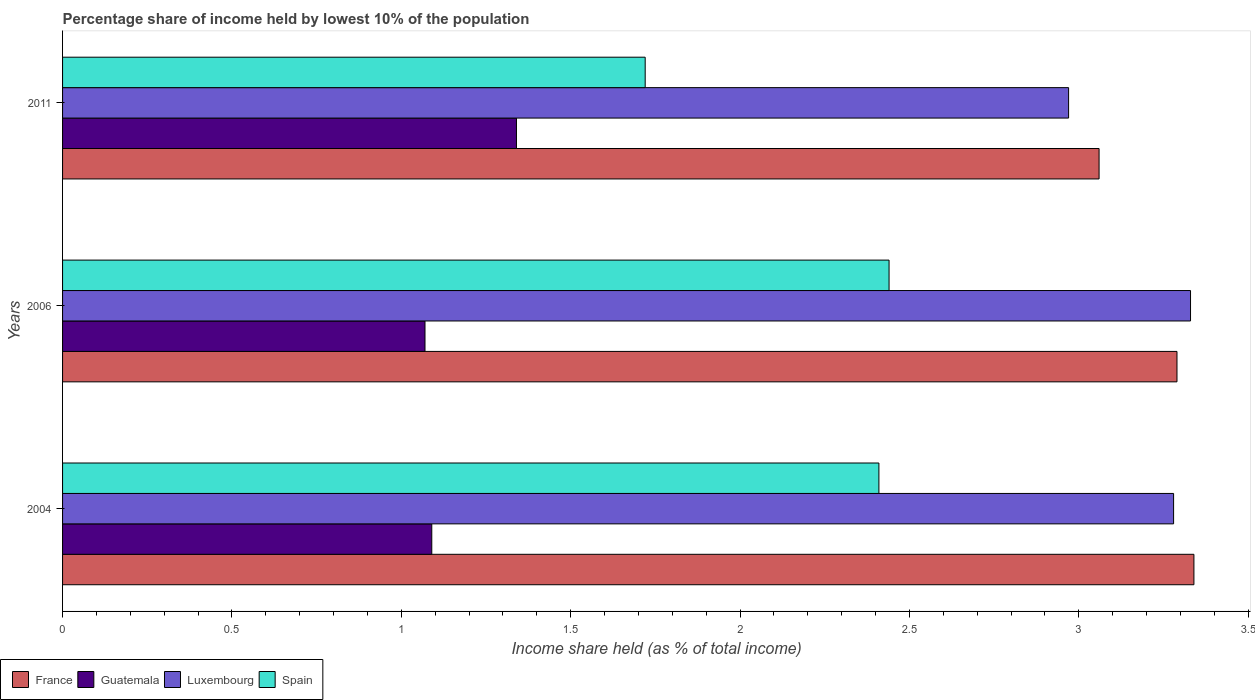How many different coloured bars are there?
Provide a short and direct response. 4. How many groups of bars are there?
Offer a terse response. 3. Are the number of bars per tick equal to the number of legend labels?
Offer a terse response. Yes. How many bars are there on the 1st tick from the top?
Ensure brevity in your answer.  4. What is the label of the 3rd group of bars from the top?
Offer a very short reply. 2004. What is the percentage share of income held by lowest 10% of the population in France in 2006?
Offer a terse response. 3.29. Across all years, what is the maximum percentage share of income held by lowest 10% of the population in France?
Your answer should be compact. 3.34. Across all years, what is the minimum percentage share of income held by lowest 10% of the population in Spain?
Offer a terse response. 1.72. What is the total percentage share of income held by lowest 10% of the population in Luxembourg in the graph?
Ensure brevity in your answer.  9.58. What is the difference between the percentage share of income held by lowest 10% of the population in Guatemala in 2006 and that in 2011?
Keep it short and to the point. -0.27. What is the difference between the percentage share of income held by lowest 10% of the population in France in 2004 and the percentage share of income held by lowest 10% of the population in Luxembourg in 2006?
Provide a short and direct response. 0.01. What is the average percentage share of income held by lowest 10% of the population in Spain per year?
Provide a short and direct response. 2.19. In the year 2011, what is the difference between the percentage share of income held by lowest 10% of the population in Guatemala and percentage share of income held by lowest 10% of the population in Luxembourg?
Your response must be concise. -1.63. What is the ratio of the percentage share of income held by lowest 10% of the population in Luxembourg in 2006 to that in 2011?
Ensure brevity in your answer.  1.12. Is the percentage share of income held by lowest 10% of the population in Luxembourg in 2004 less than that in 2011?
Offer a terse response. No. What is the difference between the highest and the lowest percentage share of income held by lowest 10% of the population in Luxembourg?
Provide a short and direct response. 0.36. In how many years, is the percentage share of income held by lowest 10% of the population in Luxembourg greater than the average percentage share of income held by lowest 10% of the population in Luxembourg taken over all years?
Your response must be concise. 2. What does the 2nd bar from the top in 2011 represents?
Offer a very short reply. Luxembourg. What does the 1st bar from the bottom in 2006 represents?
Provide a short and direct response. France. How many bars are there?
Provide a succinct answer. 12. Are all the bars in the graph horizontal?
Your response must be concise. Yes. How many years are there in the graph?
Keep it short and to the point. 3. What is the difference between two consecutive major ticks on the X-axis?
Ensure brevity in your answer.  0.5. Are the values on the major ticks of X-axis written in scientific E-notation?
Keep it short and to the point. No. Does the graph contain any zero values?
Provide a short and direct response. No. How many legend labels are there?
Your response must be concise. 4. What is the title of the graph?
Keep it short and to the point. Percentage share of income held by lowest 10% of the population. What is the label or title of the X-axis?
Provide a short and direct response. Income share held (as % of total income). What is the Income share held (as % of total income) of France in 2004?
Offer a very short reply. 3.34. What is the Income share held (as % of total income) in Guatemala in 2004?
Ensure brevity in your answer.  1.09. What is the Income share held (as % of total income) in Luxembourg in 2004?
Ensure brevity in your answer.  3.28. What is the Income share held (as % of total income) of Spain in 2004?
Make the answer very short. 2.41. What is the Income share held (as % of total income) in France in 2006?
Provide a succinct answer. 3.29. What is the Income share held (as % of total income) in Guatemala in 2006?
Give a very brief answer. 1.07. What is the Income share held (as % of total income) in Luxembourg in 2006?
Your answer should be very brief. 3.33. What is the Income share held (as % of total income) of Spain in 2006?
Your answer should be very brief. 2.44. What is the Income share held (as % of total income) in France in 2011?
Your answer should be very brief. 3.06. What is the Income share held (as % of total income) of Guatemala in 2011?
Your response must be concise. 1.34. What is the Income share held (as % of total income) in Luxembourg in 2011?
Your answer should be very brief. 2.97. What is the Income share held (as % of total income) in Spain in 2011?
Your answer should be compact. 1.72. Across all years, what is the maximum Income share held (as % of total income) of France?
Ensure brevity in your answer.  3.34. Across all years, what is the maximum Income share held (as % of total income) in Guatemala?
Offer a terse response. 1.34. Across all years, what is the maximum Income share held (as % of total income) of Luxembourg?
Your answer should be very brief. 3.33. Across all years, what is the maximum Income share held (as % of total income) in Spain?
Provide a short and direct response. 2.44. Across all years, what is the minimum Income share held (as % of total income) in France?
Provide a short and direct response. 3.06. Across all years, what is the minimum Income share held (as % of total income) of Guatemala?
Keep it short and to the point. 1.07. Across all years, what is the minimum Income share held (as % of total income) in Luxembourg?
Ensure brevity in your answer.  2.97. Across all years, what is the minimum Income share held (as % of total income) in Spain?
Ensure brevity in your answer.  1.72. What is the total Income share held (as % of total income) in France in the graph?
Make the answer very short. 9.69. What is the total Income share held (as % of total income) of Guatemala in the graph?
Your response must be concise. 3.5. What is the total Income share held (as % of total income) of Luxembourg in the graph?
Your answer should be very brief. 9.58. What is the total Income share held (as % of total income) in Spain in the graph?
Provide a succinct answer. 6.57. What is the difference between the Income share held (as % of total income) of Luxembourg in 2004 and that in 2006?
Your answer should be compact. -0.05. What is the difference between the Income share held (as % of total income) in Spain in 2004 and that in 2006?
Your answer should be compact. -0.03. What is the difference between the Income share held (as % of total income) of France in 2004 and that in 2011?
Give a very brief answer. 0.28. What is the difference between the Income share held (as % of total income) of Luxembourg in 2004 and that in 2011?
Offer a very short reply. 0.31. What is the difference between the Income share held (as % of total income) in Spain in 2004 and that in 2011?
Your answer should be compact. 0.69. What is the difference between the Income share held (as % of total income) of France in 2006 and that in 2011?
Give a very brief answer. 0.23. What is the difference between the Income share held (as % of total income) of Guatemala in 2006 and that in 2011?
Make the answer very short. -0.27. What is the difference between the Income share held (as % of total income) of Luxembourg in 2006 and that in 2011?
Keep it short and to the point. 0.36. What is the difference between the Income share held (as % of total income) in Spain in 2006 and that in 2011?
Make the answer very short. 0.72. What is the difference between the Income share held (as % of total income) in France in 2004 and the Income share held (as % of total income) in Guatemala in 2006?
Make the answer very short. 2.27. What is the difference between the Income share held (as % of total income) of France in 2004 and the Income share held (as % of total income) of Luxembourg in 2006?
Your answer should be compact. 0.01. What is the difference between the Income share held (as % of total income) in Guatemala in 2004 and the Income share held (as % of total income) in Luxembourg in 2006?
Make the answer very short. -2.24. What is the difference between the Income share held (as % of total income) of Guatemala in 2004 and the Income share held (as % of total income) of Spain in 2006?
Keep it short and to the point. -1.35. What is the difference between the Income share held (as % of total income) in Luxembourg in 2004 and the Income share held (as % of total income) in Spain in 2006?
Make the answer very short. 0.84. What is the difference between the Income share held (as % of total income) in France in 2004 and the Income share held (as % of total income) in Guatemala in 2011?
Provide a succinct answer. 2. What is the difference between the Income share held (as % of total income) in France in 2004 and the Income share held (as % of total income) in Luxembourg in 2011?
Provide a succinct answer. 0.37. What is the difference between the Income share held (as % of total income) in France in 2004 and the Income share held (as % of total income) in Spain in 2011?
Keep it short and to the point. 1.62. What is the difference between the Income share held (as % of total income) in Guatemala in 2004 and the Income share held (as % of total income) in Luxembourg in 2011?
Your answer should be compact. -1.88. What is the difference between the Income share held (as % of total income) in Guatemala in 2004 and the Income share held (as % of total income) in Spain in 2011?
Offer a terse response. -0.63. What is the difference between the Income share held (as % of total income) of Luxembourg in 2004 and the Income share held (as % of total income) of Spain in 2011?
Make the answer very short. 1.56. What is the difference between the Income share held (as % of total income) in France in 2006 and the Income share held (as % of total income) in Guatemala in 2011?
Provide a succinct answer. 1.95. What is the difference between the Income share held (as % of total income) of France in 2006 and the Income share held (as % of total income) of Luxembourg in 2011?
Your answer should be very brief. 0.32. What is the difference between the Income share held (as % of total income) of France in 2006 and the Income share held (as % of total income) of Spain in 2011?
Your answer should be compact. 1.57. What is the difference between the Income share held (as % of total income) in Guatemala in 2006 and the Income share held (as % of total income) in Spain in 2011?
Offer a very short reply. -0.65. What is the difference between the Income share held (as % of total income) in Luxembourg in 2006 and the Income share held (as % of total income) in Spain in 2011?
Your answer should be compact. 1.61. What is the average Income share held (as % of total income) in France per year?
Ensure brevity in your answer.  3.23. What is the average Income share held (as % of total income) of Luxembourg per year?
Provide a short and direct response. 3.19. What is the average Income share held (as % of total income) of Spain per year?
Give a very brief answer. 2.19. In the year 2004, what is the difference between the Income share held (as % of total income) of France and Income share held (as % of total income) of Guatemala?
Ensure brevity in your answer.  2.25. In the year 2004, what is the difference between the Income share held (as % of total income) of France and Income share held (as % of total income) of Luxembourg?
Ensure brevity in your answer.  0.06. In the year 2004, what is the difference between the Income share held (as % of total income) in Guatemala and Income share held (as % of total income) in Luxembourg?
Your answer should be compact. -2.19. In the year 2004, what is the difference between the Income share held (as % of total income) of Guatemala and Income share held (as % of total income) of Spain?
Provide a succinct answer. -1.32. In the year 2004, what is the difference between the Income share held (as % of total income) in Luxembourg and Income share held (as % of total income) in Spain?
Provide a short and direct response. 0.87. In the year 2006, what is the difference between the Income share held (as % of total income) in France and Income share held (as % of total income) in Guatemala?
Offer a terse response. 2.22. In the year 2006, what is the difference between the Income share held (as % of total income) in France and Income share held (as % of total income) in Luxembourg?
Your answer should be compact. -0.04. In the year 2006, what is the difference between the Income share held (as % of total income) in France and Income share held (as % of total income) in Spain?
Ensure brevity in your answer.  0.85. In the year 2006, what is the difference between the Income share held (as % of total income) in Guatemala and Income share held (as % of total income) in Luxembourg?
Keep it short and to the point. -2.26. In the year 2006, what is the difference between the Income share held (as % of total income) of Guatemala and Income share held (as % of total income) of Spain?
Provide a short and direct response. -1.37. In the year 2006, what is the difference between the Income share held (as % of total income) in Luxembourg and Income share held (as % of total income) in Spain?
Provide a succinct answer. 0.89. In the year 2011, what is the difference between the Income share held (as % of total income) of France and Income share held (as % of total income) of Guatemala?
Provide a succinct answer. 1.72. In the year 2011, what is the difference between the Income share held (as % of total income) in France and Income share held (as % of total income) in Luxembourg?
Offer a terse response. 0.09. In the year 2011, what is the difference between the Income share held (as % of total income) of France and Income share held (as % of total income) of Spain?
Your answer should be compact. 1.34. In the year 2011, what is the difference between the Income share held (as % of total income) in Guatemala and Income share held (as % of total income) in Luxembourg?
Your response must be concise. -1.63. In the year 2011, what is the difference between the Income share held (as % of total income) in Guatemala and Income share held (as % of total income) in Spain?
Your response must be concise. -0.38. What is the ratio of the Income share held (as % of total income) of France in 2004 to that in 2006?
Make the answer very short. 1.02. What is the ratio of the Income share held (as % of total income) in Guatemala in 2004 to that in 2006?
Your answer should be compact. 1.02. What is the ratio of the Income share held (as % of total income) of Spain in 2004 to that in 2006?
Make the answer very short. 0.99. What is the ratio of the Income share held (as % of total income) in France in 2004 to that in 2011?
Your response must be concise. 1.09. What is the ratio of the Income share held (as % of total income) of Guatemala in 2004 to that in 2011?
Provide a short and direct response. 0.81. What is the ratio of the Income share held (as % of total income) in Luxembourg in 2004 to that in 2011?
Provide a succinct answer. 1.1. What is the ratio of the Income share held (as % of total income) in Spain in 2004 to that in 2011?
Ensure brevity in your answer.  1.4. What is the ratio of the Income share held (as % of total income) of France in 2006 to that in 2011?
Your answer should be very brief. 1.08. What is the ratio of the Income share held (as % of total income) of Guatemala in 2006 to that in 2011?
Provide a succinct answer. 0.8. What is the ratio of the Income share held (as % of total income) in Luxembourg in 2006 to that in 2011?
Ensure brevity in your answer.  1.12. What is the ratio of the Income share held (as % of total income) of Spain in 2006 to that in 2011?
Make the answer very short. 1.42. What is the difference between the highest and the second highest Income share held (as % of total income) of Luxembourg?
Provide a succinct answer. 0.05. What is the difference between the highest and the second highest Income share held (as % of total income) in Spain?
Offer a terse response. 0.03. What is the difference between the highest and the lowest Income share held (as % of total income) of France?
Offer a very short reply. 0.28. What is the difference between the highest and the lowest Income share held (as % of total income) of Guatemala?
Offer a terse response. 0.27. What is the difference between the highest and the lowest Income share held (as % of total income) in Luxembourg?
Keep it short and to the point. 0.36. What is the difference between the highest and the lowest Income share held (as % of total income) of Spain?
Make the answer very short. 0.72. 